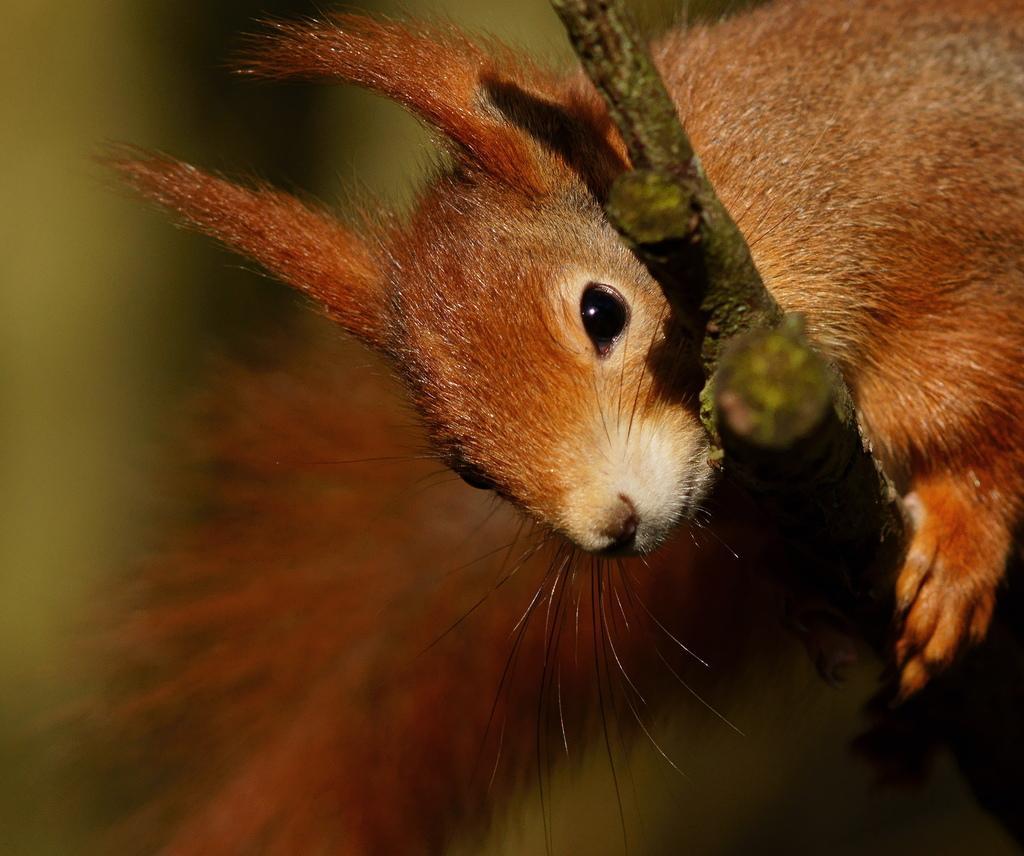Describe this image in one or two sentences. In this image we can see a squirrel on the wooden stick, and the background is blurred. 